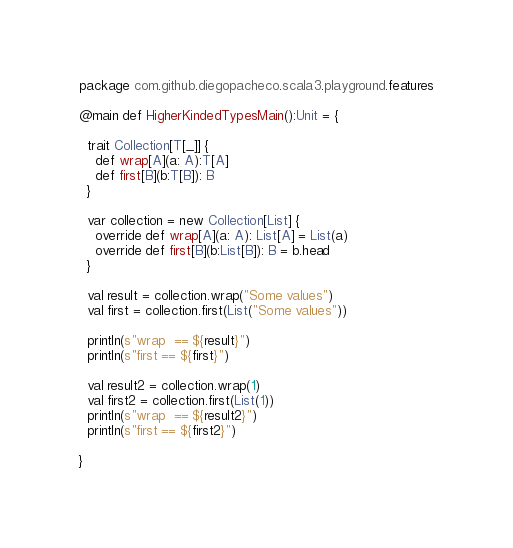<code> <loc_0><loc_0><loc_500><loc_500><_Scala_>package com.github.diegopacheco.scala3.playground.features

@main def HigherKindedTypesMain():Unit = {

  trait Collection[T[_]] {
    def wrap[A](a: A):T[A]
    def first[B](b:T[B]): B
  }

  var collection = new Collection[List] {
    override def wrap[A](a: A): List[A] = List(a)
    override def first[B](b:List[B]): B = b.head
  }
  
  val result = collection.wrap("Some values")
  val first = collection.first(List("Some values"))

  println(s"wrap  == ${result}") 
  println(s"first == ${first}")

  val result2 = collection.wrap(1)
  val first2 = collection.first(List(1))
  println(s"wrap  == ${result2}")
  println(s"first == ${first2}")
  
}
</code> 